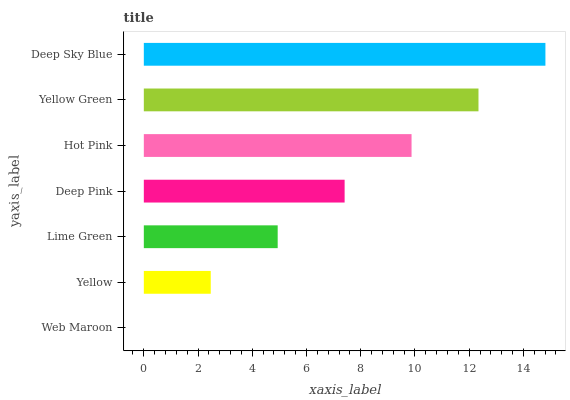Is Web Maroon the minimum?
Answer yes or no. Yes. Is Deep Sky Blue the maximum?
Answer yes or no. Yes. Is Yellow the minimum?
Answer yes or no. No. Is Yellow the maximum?
Answer yes or no. No. Is Yellow greater than Web Maroon?
Answer yes or no. Yes. Is Web Maroon less than Yellow?
Answer yes or no. Yes. Is Web Maroon greater than Yellow?
Answer yes or no. No. Is Yellow less than Web Maroon?
Answer yes or no. No. Is Deep Pink the high median?
Answer yes or no. Yes. Is Deep Pink the low median?
Answer yes or no. Yes. Is Web Maroon the high median?
Answer yes or no. No. Is Web Maroon the low median?
Answer yes or no. No. 